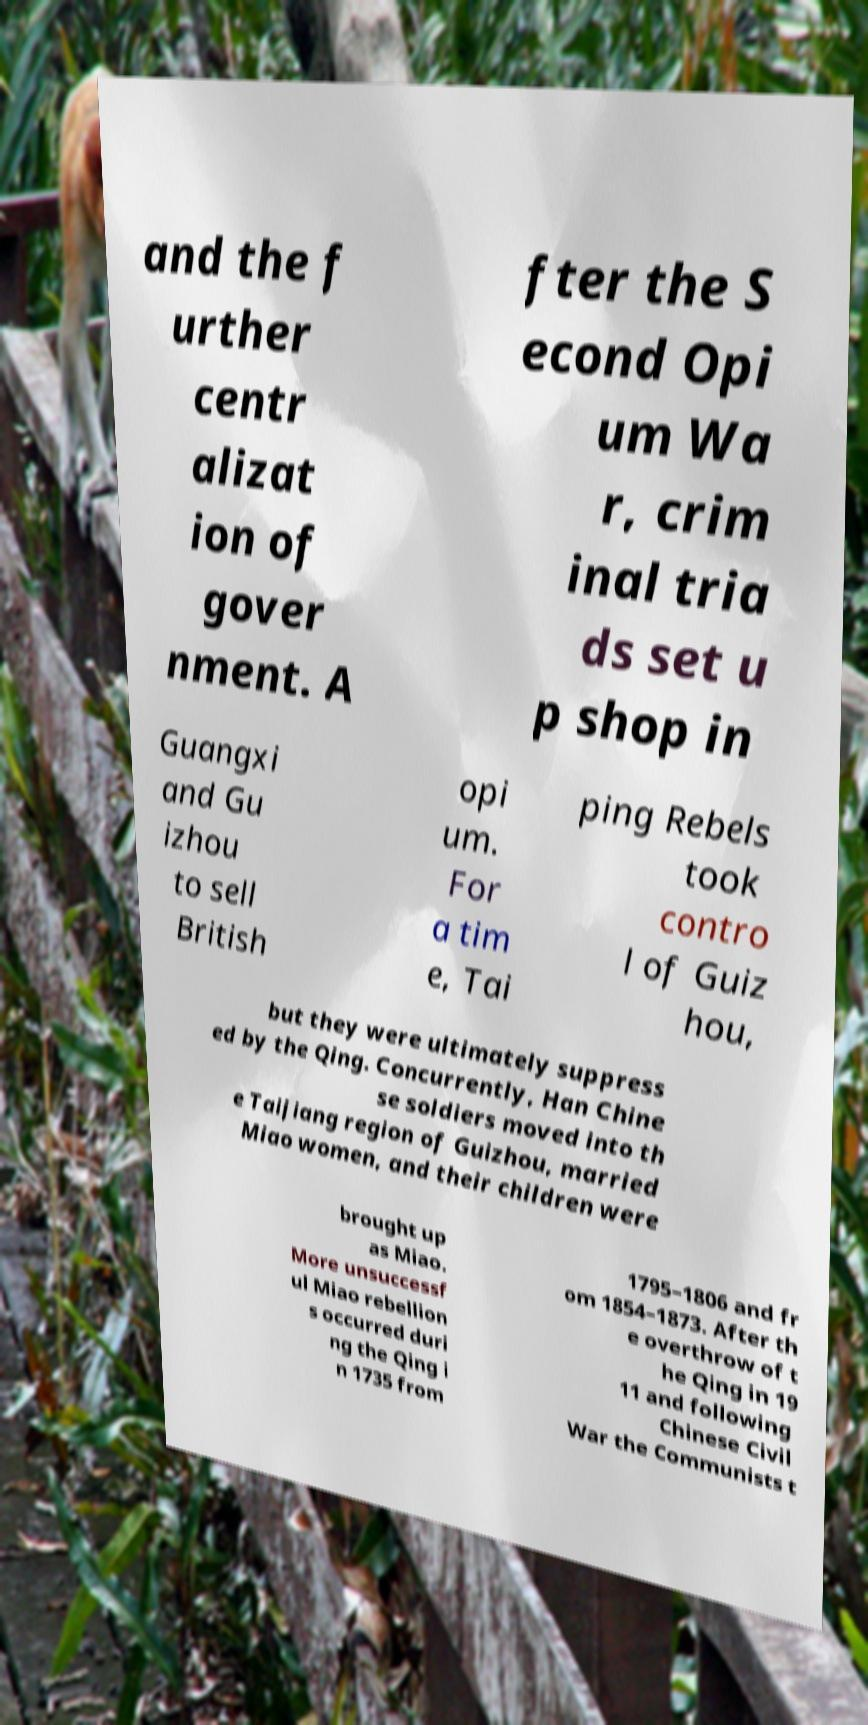Can you read and provide the text displayed in the image?This photo seems to have some interesting text. Can you extract and type it out for me? and the f urther centr alizat ion of gover nment. A fter the S econd Opi um Wa r, crim inal tria ds set u p shop in Guangxi and Gu izhou to sell British opi um. For a tim e, Tai ping Rebels took contro l of Guiz hou, but they were ultimately suppress ed by the Qing. Concurrently, Han Chine se soldiers moved into th e Taijiang region of Guizhou, married Miao women, and their children were brought up as Miao. More unsuccessf ul Miao rebellion s occurred duri ng the Qing i n 1735 from 1795–1806 and fr om 1854–1873. After th e overthrow of t he Qing in 19 11 and following Chinese Civil War the Communists t 